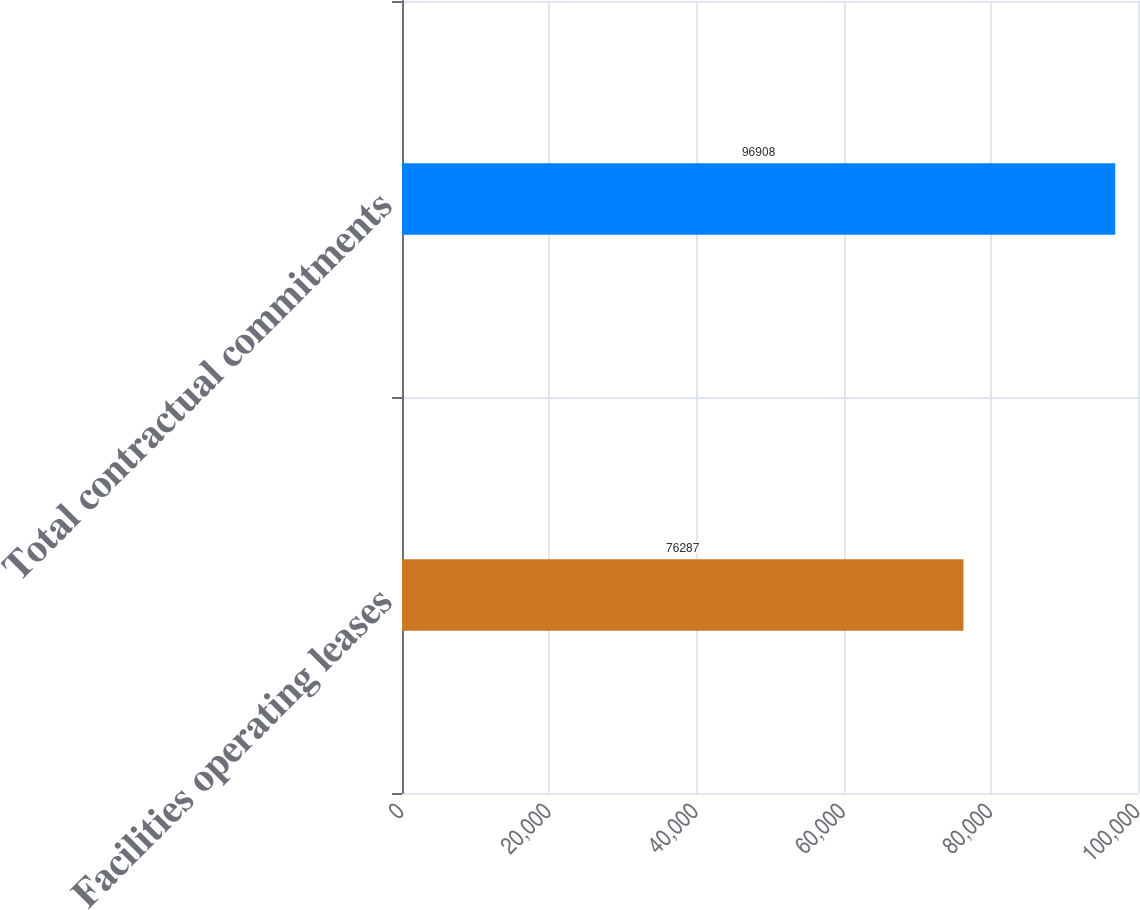Convert chart to OTSL. <chart><loc_0><loc_0><loc_500><loc_500><bar_chart><fcel>Facilities operating leases<fcel>Total contractual commitments<nl><fcel>76287<fcel>96908<nl></chart> 